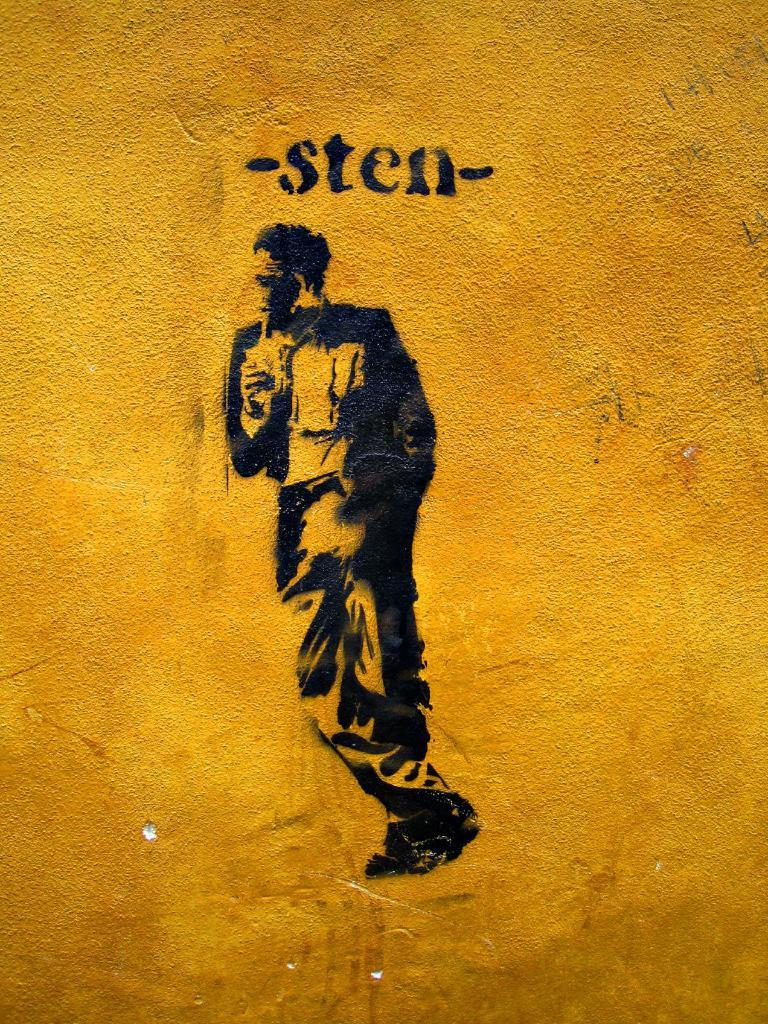<image>
Relay a brief, clear account of the picture shown. a man that has the name sten above him 